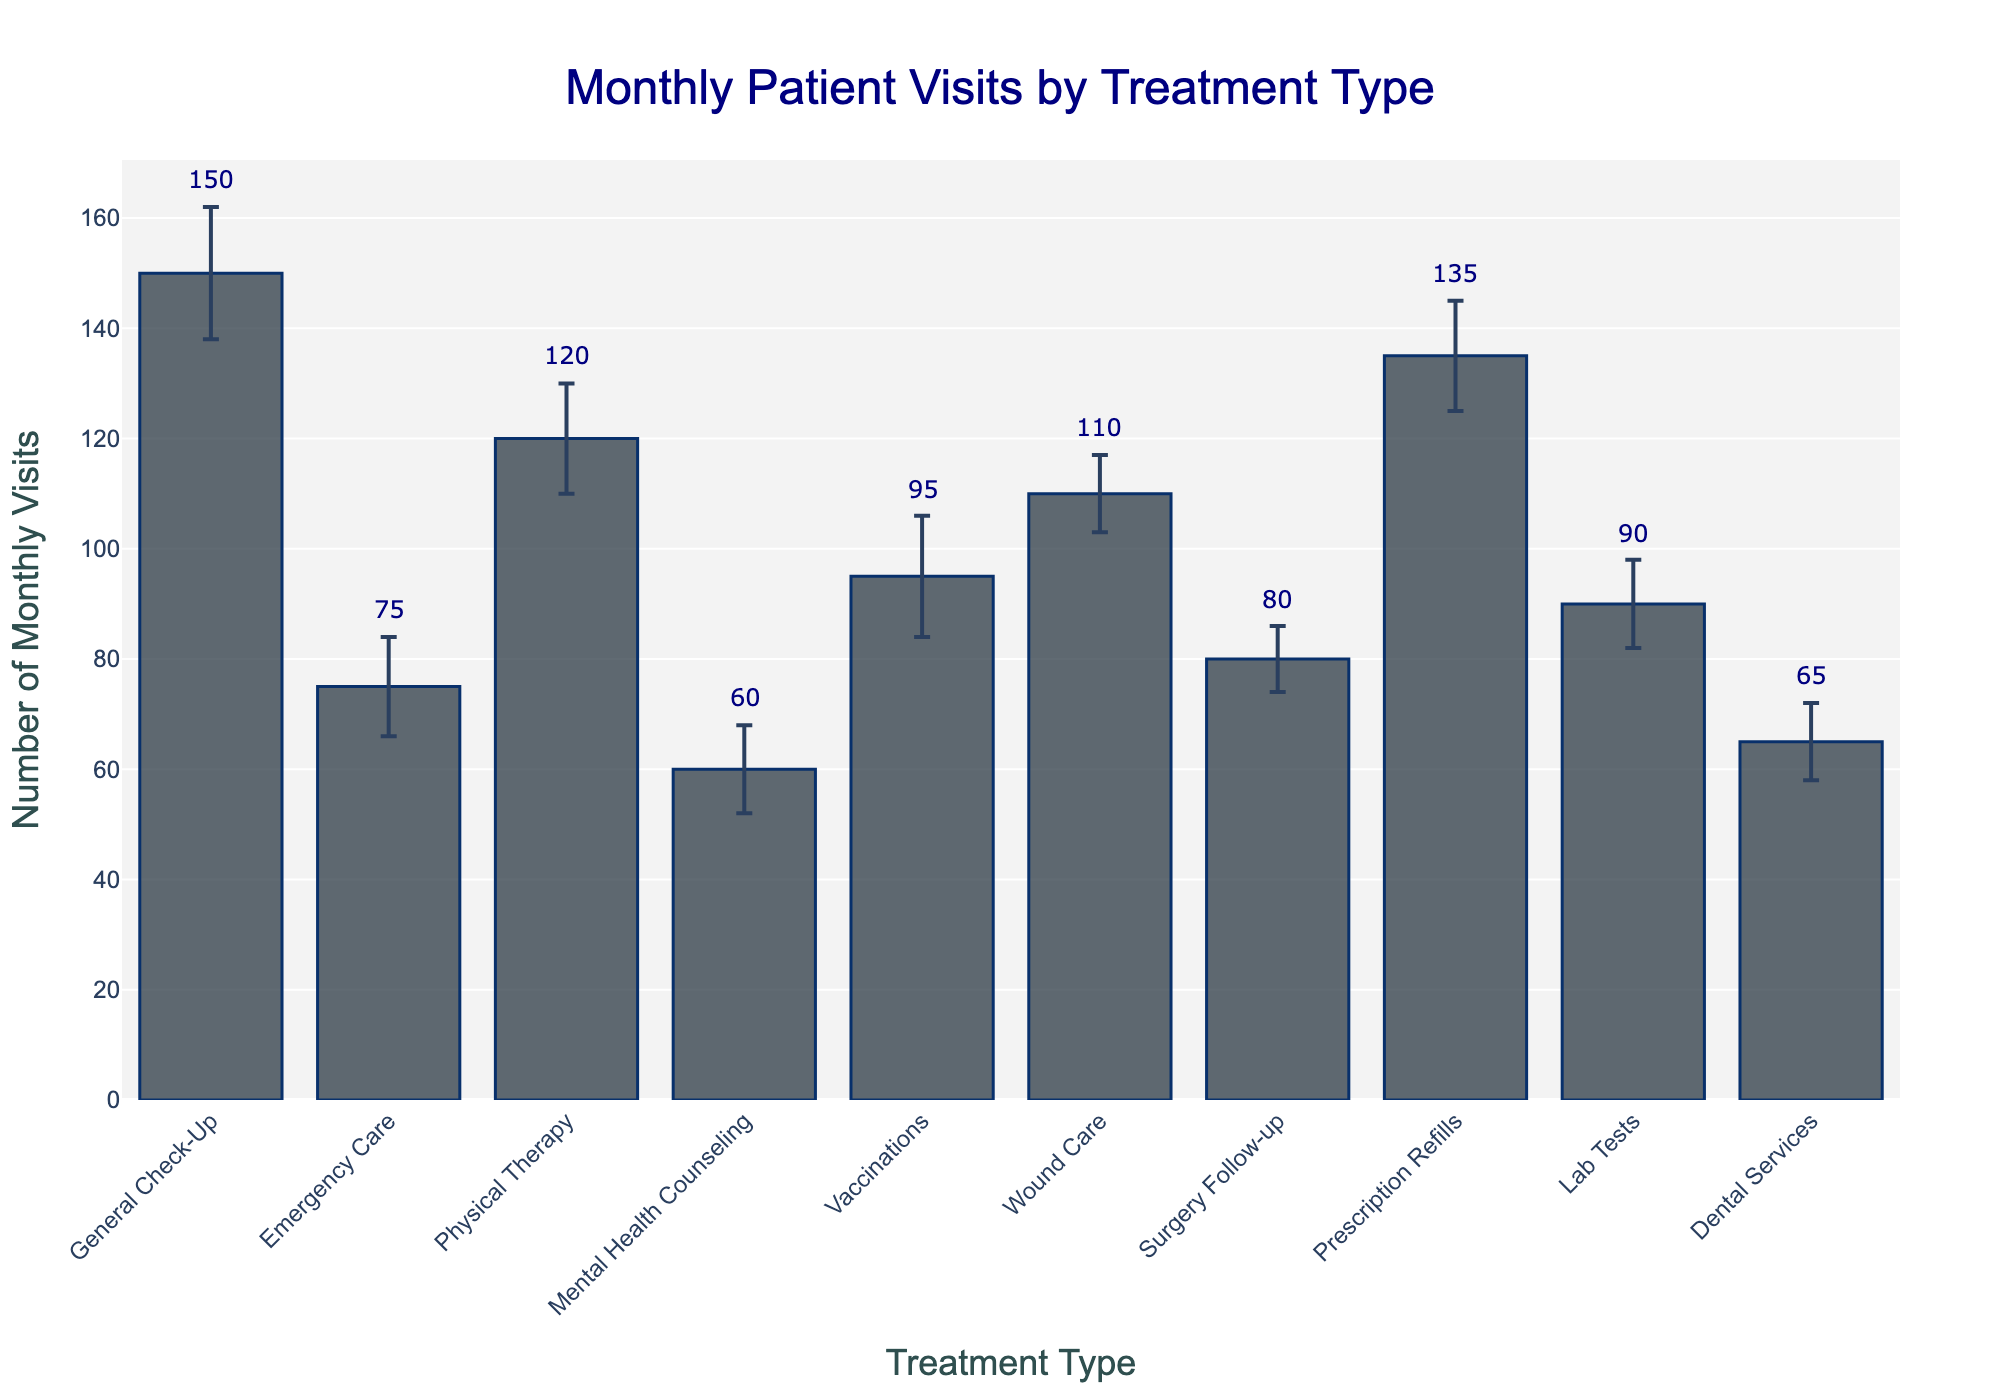What's the title of the chart? The title is displayed prominently at the top of the chart.
Answer: Monthly Patient Visits by Treatment Type What is the treatment type with the highest number of monthly visits? The tallest bar in the chart is for the General Check-Up treatment, indicating it has the highest number of monthly visits.
Answer: General Check-Up Which treatment type has the smallest standard error? The smallest error bars can be visually identified as those surrounding the Surgery Follow-up bar.
Answer: Surgery Follow-up How many treatment types have more than 100 monthly visits? By counting the bars with heights above the 100-mark on the y-axis, we find out there are four treatment types: General Check-Up, Physical Therapy, Wound Care, and Prescription Refills.
Answer: Four What is the range of the number of monthly visits for Dental Services? The value for Dental Services is given as 65 with a standard error of 7. Hence, the range is from 65 - 7 to 65 + 7.
Answer: 58 to 72 What's the average number of monthly visits across all treatment types? Sum all the monthly visits values (150 + 75 + 120 + 60 + 95 + 110 + 80 + 135 + 90 + 65) = 980. There are 10 treatment types, so the average is 980/10.
Answer: 98 Which treatment type has a higher number of monthly visits: Vaccinations or Lab Tests? By comparing the heights of the bars for Vaccinations (95) and Lab Tests (90), we see that Vaccinations have more monthly visits.
Answer: Vaccinations What is the total number of monthly visits for Emergency Care and Dental Services combined? Add the values for Emergency Care and Dental Services: 75 + 65.
Answer: 140 Which treatment type's error margin overlaps with 100 monthly visits? Looking at the treatment types with their error margins, we see both Vaccinations (95, SE=11) and Wound Care (110, SE=7) have ranges that include 100.
Answer: Vaccinations and Wound Care What is the difference in the number of monthly visits between Prescription Refills and Surgery Follow-up? Subtract the monthly visits of Surgery Follow-up from Prescription Refills: 135 - 80.
Answer: 55 